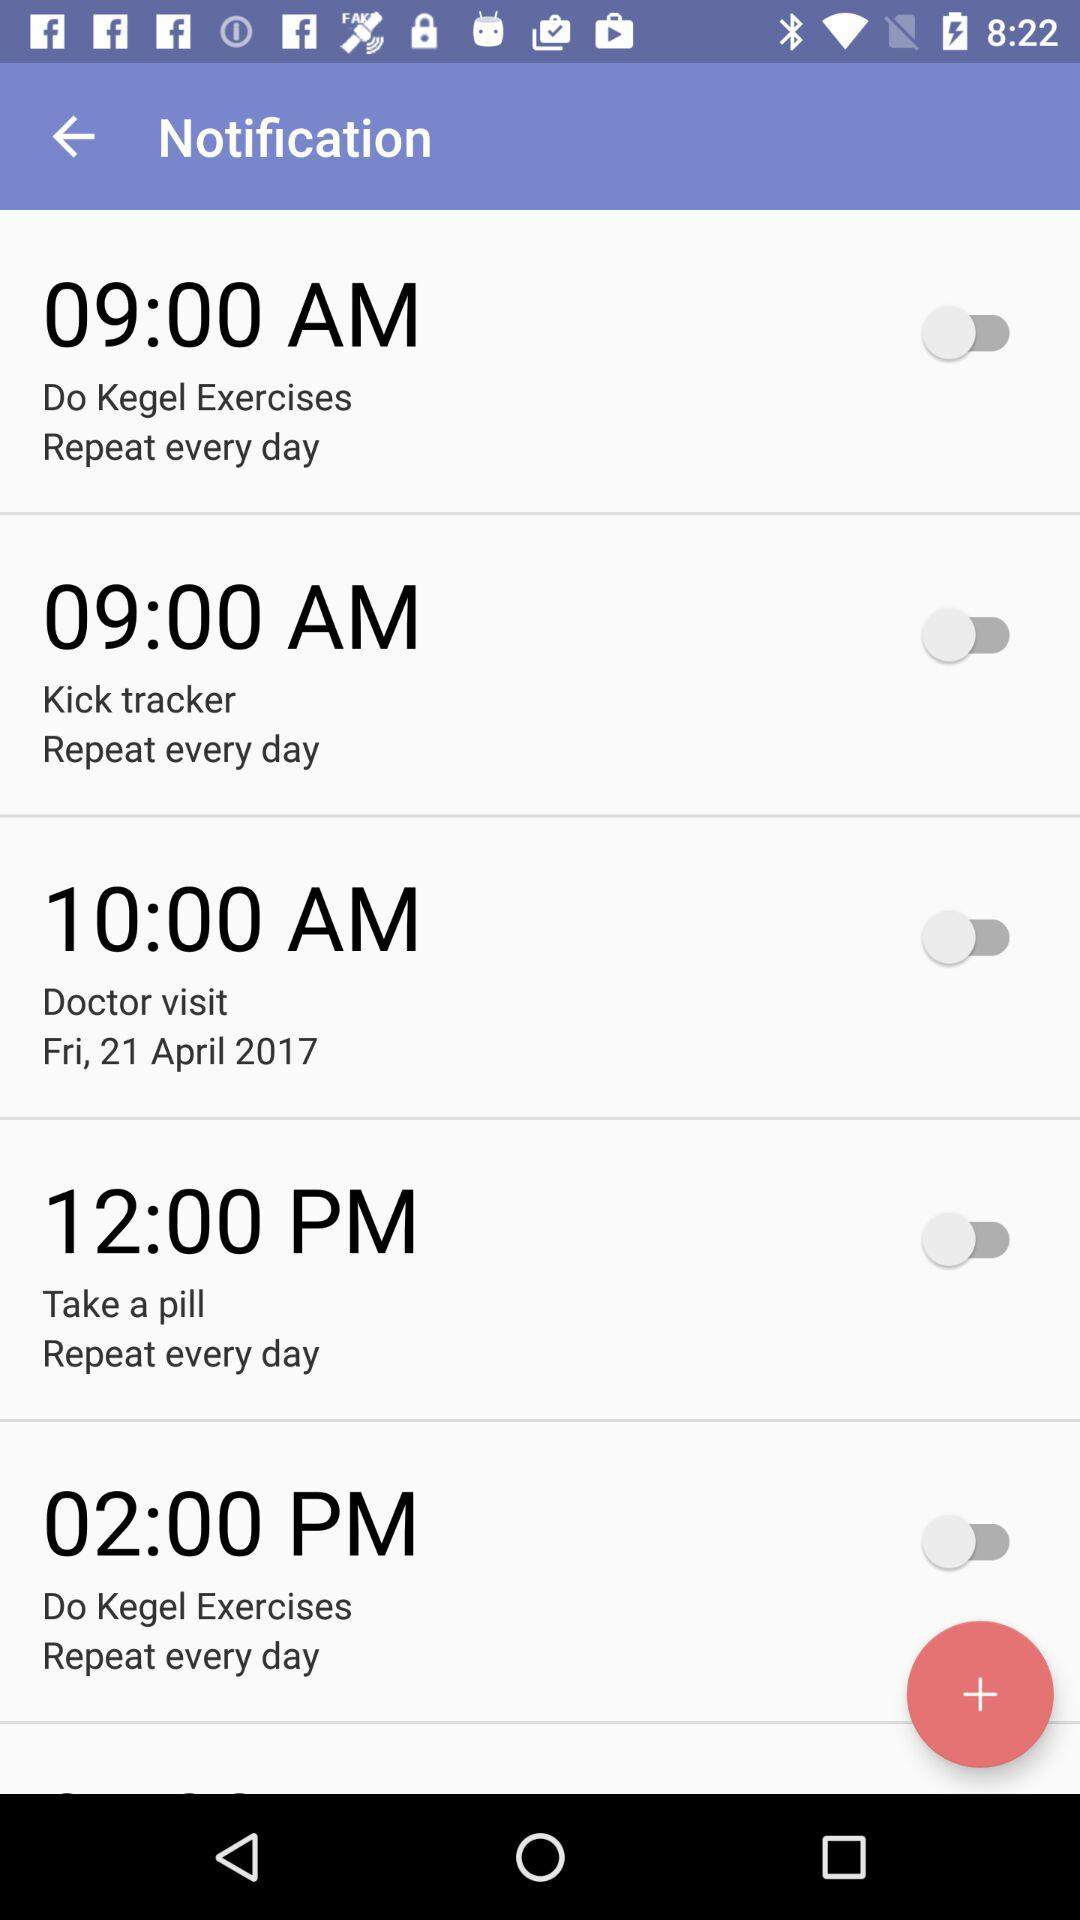When is the time to take a pill? The time is 12:00 PM. 